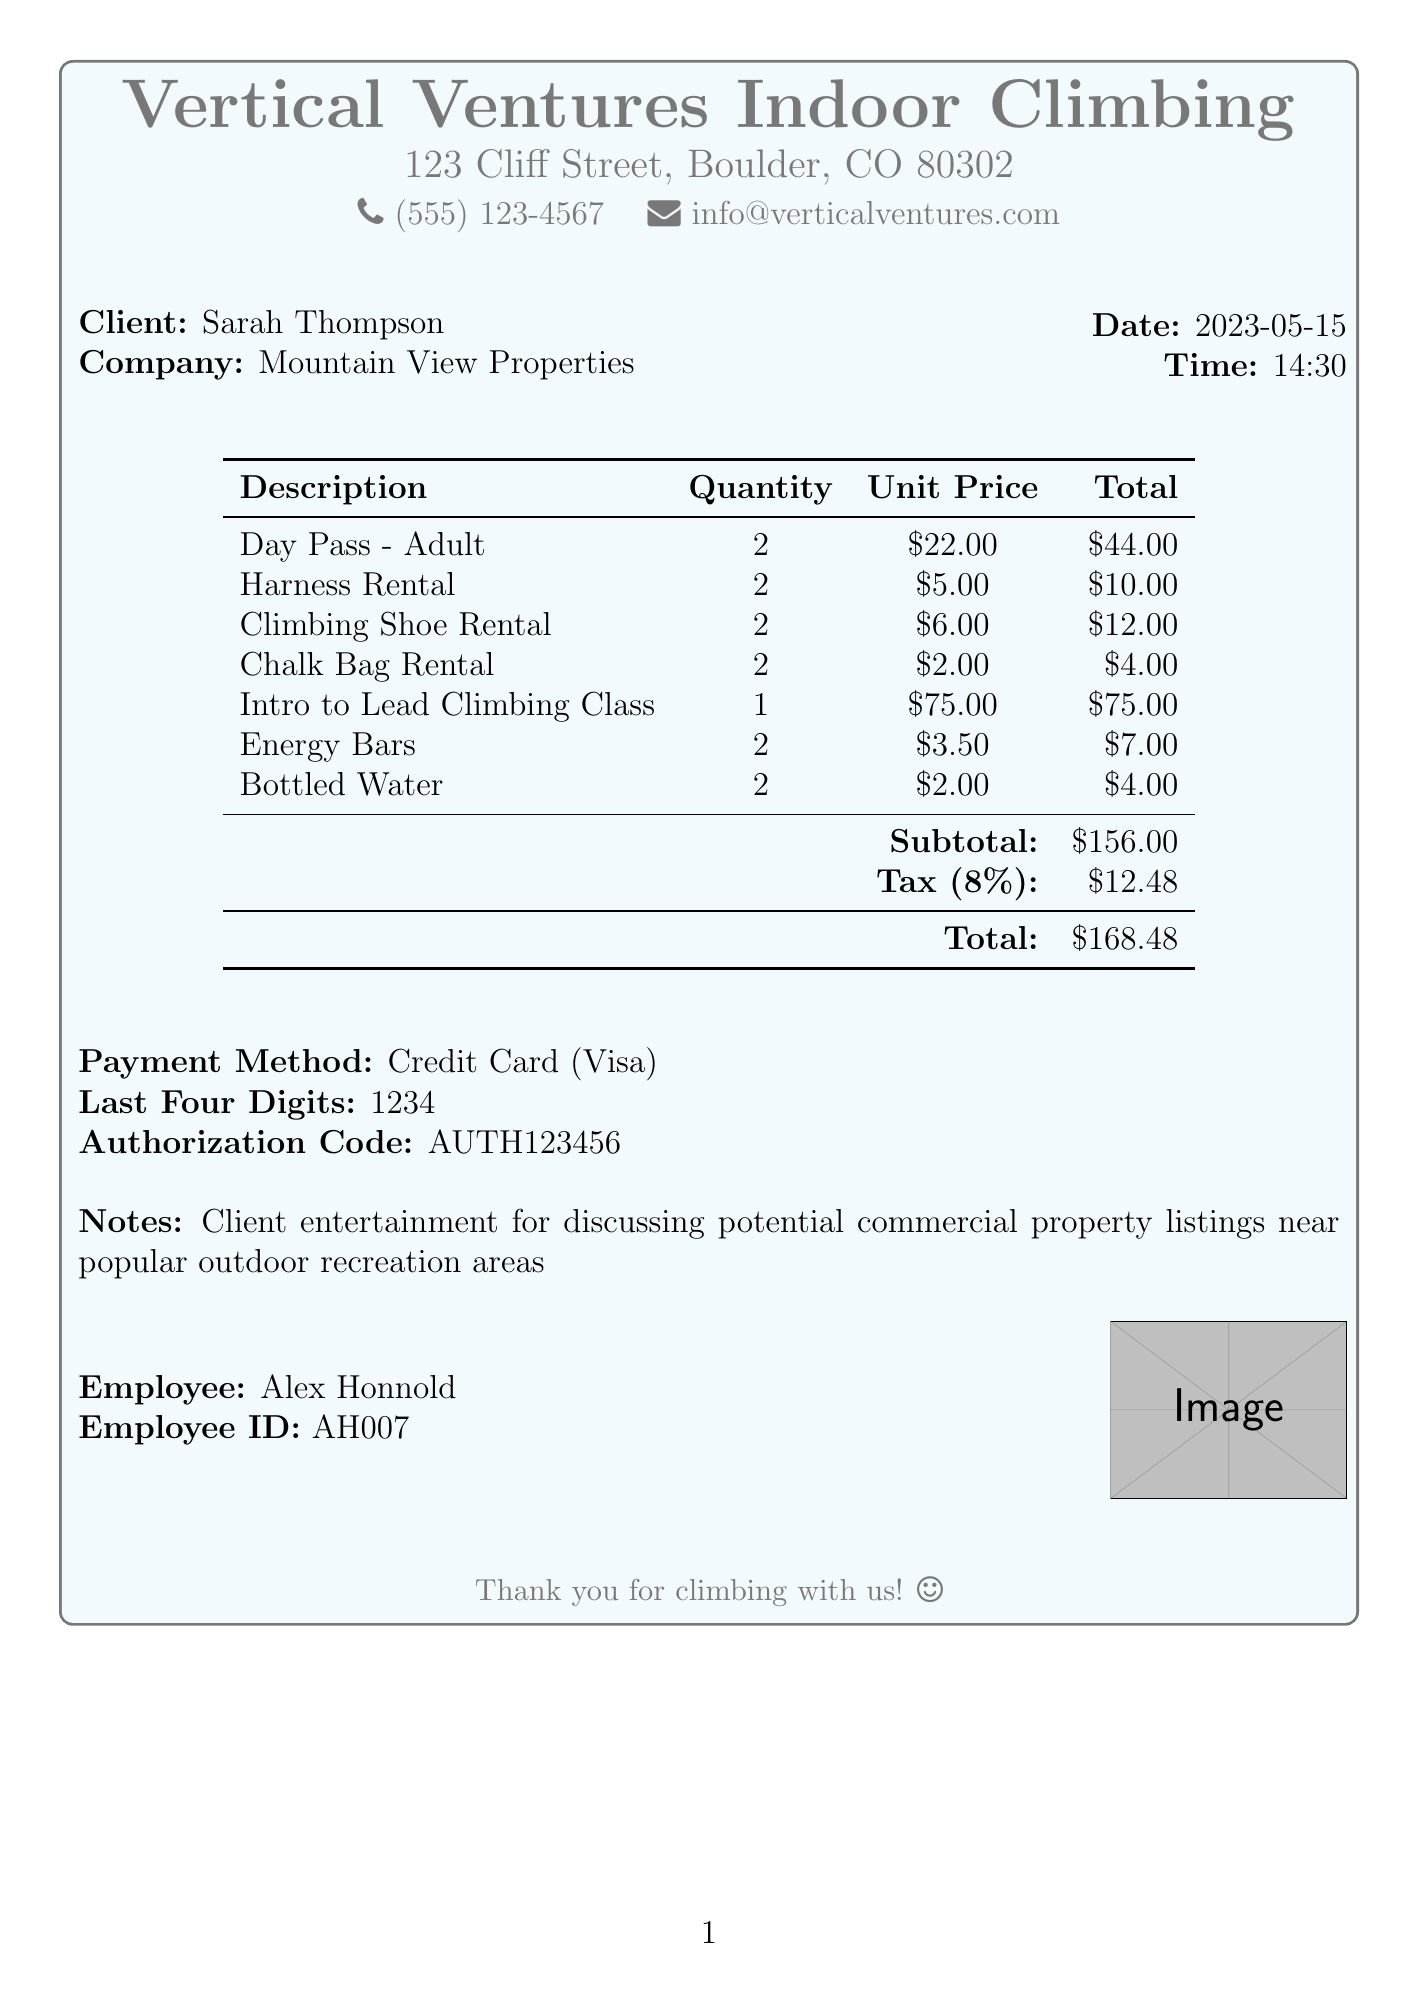What is the business name? The business name is clearly stated at the top of the receipt.
Answer: Vertical Ventures Indoor Climbing Who is the client? The client's name is mentioned in the client details section of the document.
Answer: Sarah Thompson What is the total amount? The total amount is provided at the end of the itemized expenses.
Answer: $168.48 How many energy bars were purchased? The quantity of energy bars is specified in the itemized list.
Answer: 2 What was the date of the transaction? The date is mentioned in the header section of the receipt.
Answer: 2023-05-15 What type of class was attended? The type of class is listed among the items purchased.
Answer: Intro to Lead Climbing Class What is the subtotal before tax? The subtotal is provided before tax calculations in the document.
Answer: $156.00 How much was spent on equipment rentals? This is found by adding the total amounts for the rental items.
Answer: $26.00 Who is the employee that processed the transaction? The employee's name is included near the bottom of the receipt.
Answer: Alex Honnold 